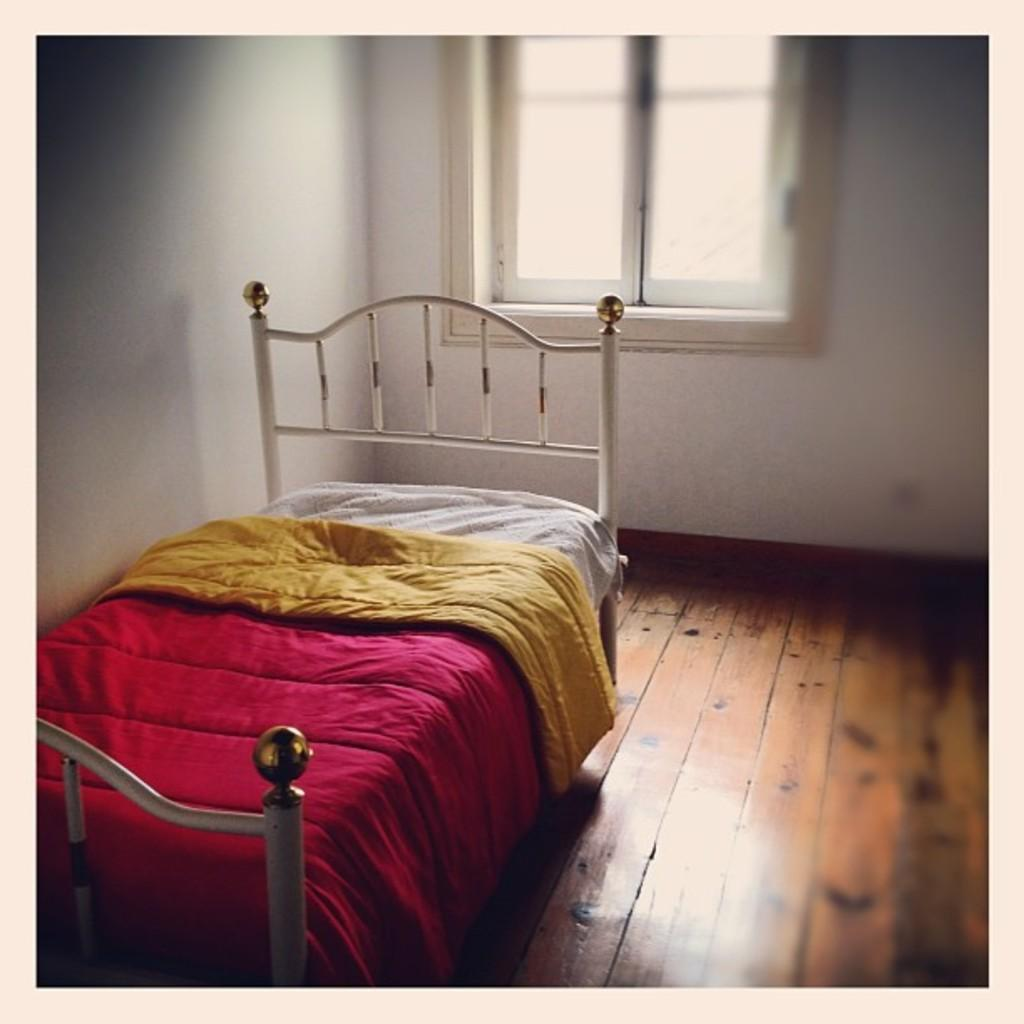What is the main object in the image? There is a bed with blankets in the image. What can be seen in the background of the image? There are walls and a window in the background of the image. What type of board game is being played on the bed in the image? There is no board game present in the image; it only features a bed with blankets and a background with walls and a window. 